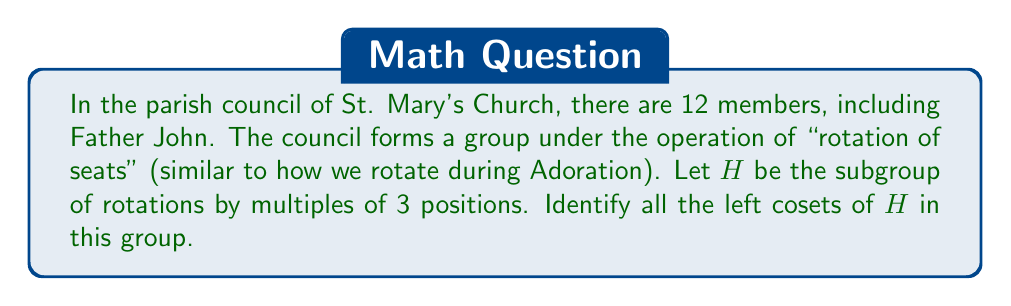Solve this math problem. Let's approach this step-by-step:

1) First, we need to understand the group and subgroup:
   - The group $G$ consists of all 12 rotations (including the identity rotation).
   - The subgroup $H$ consists of rotations by multiples of 3 positions.

2) The elements of $H$ are:
   $$H = \{e, r^3, r^6, r^9\}$$
   where $e$ is the identity rotation and $r^n$ represents a rotation by $n$ positions.

3) To find the left cosets, we need to multiply $H$ by each element of $G$ from the left:

   For $r^0 = e$: $eH = H = \{e, r^3, r^6, r^9\}$
   
   For $r^1$: $r^1H = \{r^1, r^4, r^7, r^{10}\}$
   
   For $r^2$: $r^2H = \{r^2, r^5, r^8, r^{11}\}$

4) We can observe that:
   $r^3H = H$
   $r^4H = r^1H$
   $r^5H = r^2H$
   and so on...

5) Therefore, there are only three distinct left cosets:
   $$H, r^1H, r^2H$$

This reflects the fact that $|G:H| = |G|/|H| = 12/4 = 3$, where $|G:H|$ is the index of $H$ in $G$.
Answer: The left cosets of $H$ in $G$ are:
$$H = \{e, r^3, r^6, r^9\}$$
$$r^1H = \{r^1, r^4, r^7, r^{10}\}$$
$$r^2H = \{r^2, r^5, r^8, r^{11}\}$$ 